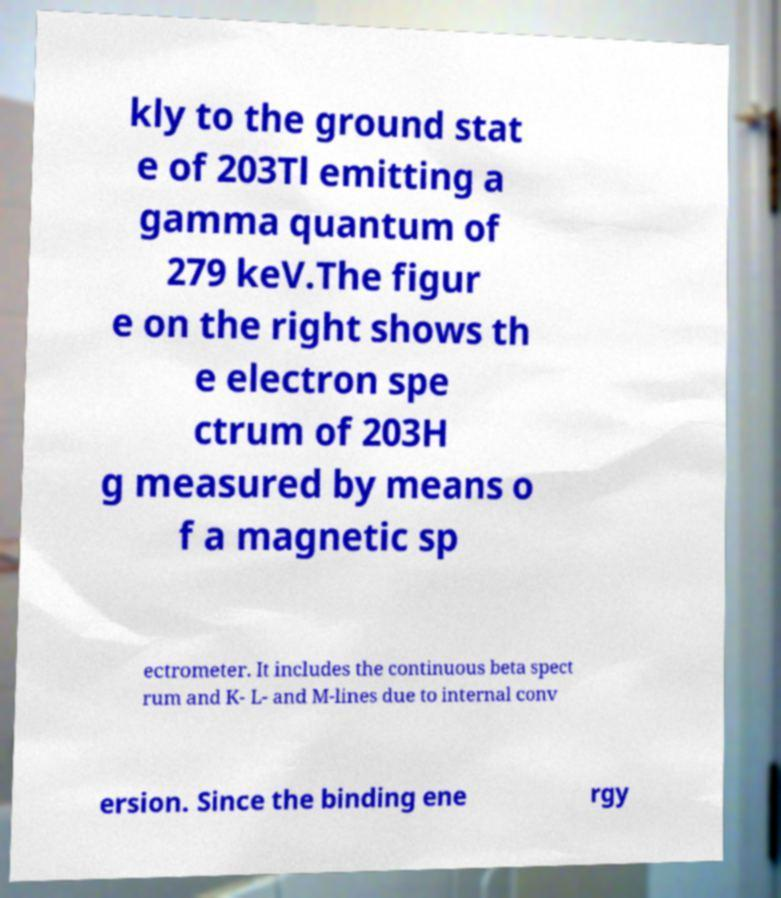What messages or text are displayed in this image? I need them in a readable, typed format. kly to the ground stat e of 203Tl emitting a gamma quantum of 279 keV.The figur e on the right shows th e electron spe ctrum of 203H g measured by means o f a magnetic sp ectrometer. It includes the continuous beta spect rum and K- L- and M-lines due to internal conv ersion. Since the binding ene rgy 